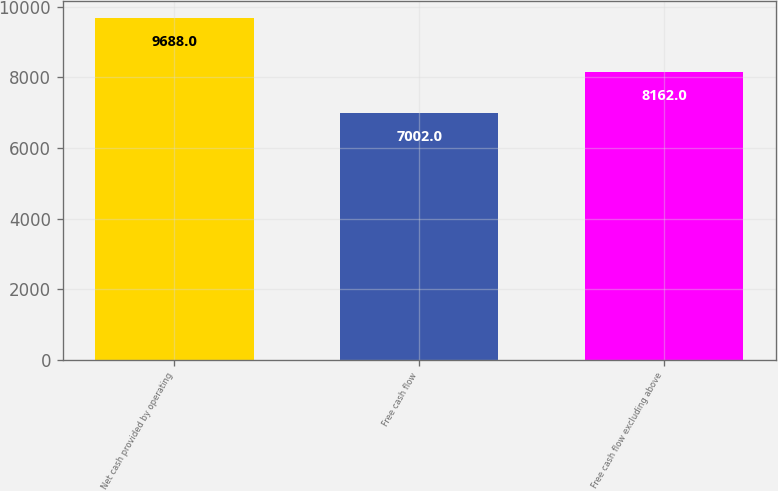Convert chart to OTSL. <chart><loc_0><loc_0><loc_500><loc_500><bar_chart><fcel>Net cash provided by operating<fcel>Free cash flow<fcel>Free cash flow excluding above<nl><fcel>9688<fcel>7002<fcel>8162<nl></chart> 